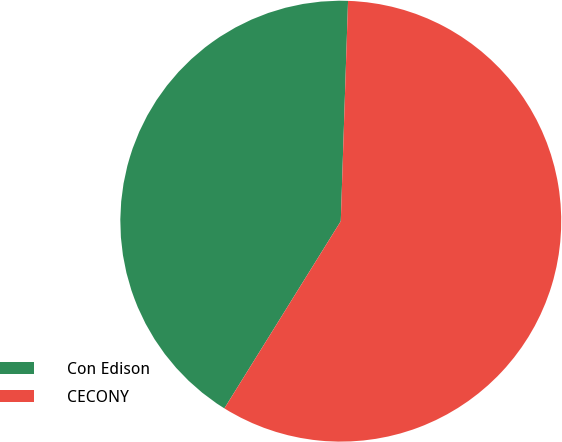<chart> <loc_0><loc_0><loc_500><loc_500><pie_chart><fcel>Con Edison<fcel>CECONY<nl><fcel>41.67%<fcel>58.33%<nl></chart> 